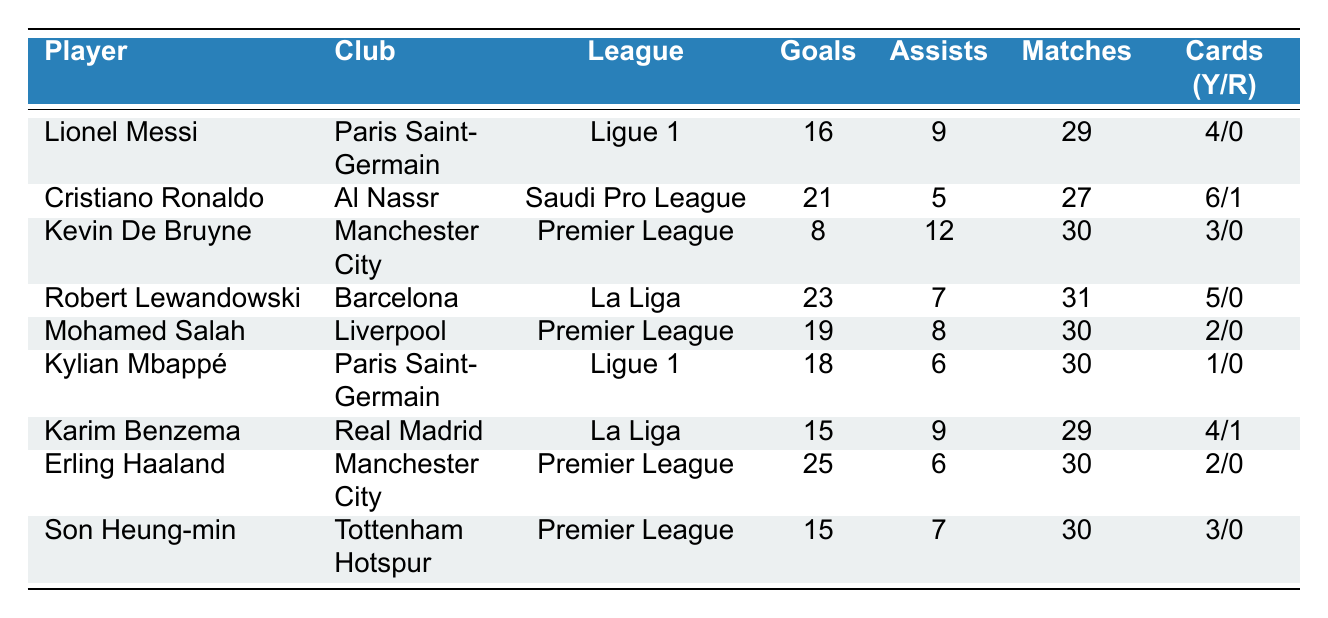What player scored the most goals? Looking at the table, Erling Haaland has the highest goals scored with 25.
Answer: Erling Haaland How many assists did Kevin De Bruyne have? The table shows that Kevin De Bruyne recorded 12 assists.
Answer: 12 assists Which player has the highest number of yellow cards? By examining the cards column, Cristiano Ronaldo has the highest number of yellow cards at 6.
Answer: Cristiano Ronaldo How many total goals did players from Ligue 1 score? Adding the goals of Messi (16) and Mbappé (18) in Ligue 1, we get a total of 34 goals (16 + 18).
Answer: 34 goals Did any player receive a red card? Yes, according to the table, Cristiano Ronaldo and Karim Benzema both received 1 red card each.
Answer: Yes Which league had the player with the most assists? In the Premier League, Kevin De Bruyne had the most assists (12) compared to players in other leagues.
Answer: Premier League What is the average number of goals scored by La Liga players? Robert Lewandowski (23) and Karim Benzema (15) play in La Liga. Their total is 38 goals. The average (38 / 2) is 19.
Answer: 19 goals How many matches did Mohamed Salah play? The table indicates that Mohamed Salah played 30 matches.
Answer: 30 matches Which player had more assists: Kylian Mbappé or Mohamed Salah? Kylian Mbappé had 6 assists while Mohamed Salah had 8 assists. Thus, Salah had more assists.
Answer: Mohamed Salah If we consider only the players with no red cards, who scored the most goals? Erling Haaland (25), Messi (16), Mbappé (18), De Bruyne (8), Salah (19), and Son Heung-min (15) all have no red cards. The highest is Haaland with 25 goals.
Answer: Erling Haaland 